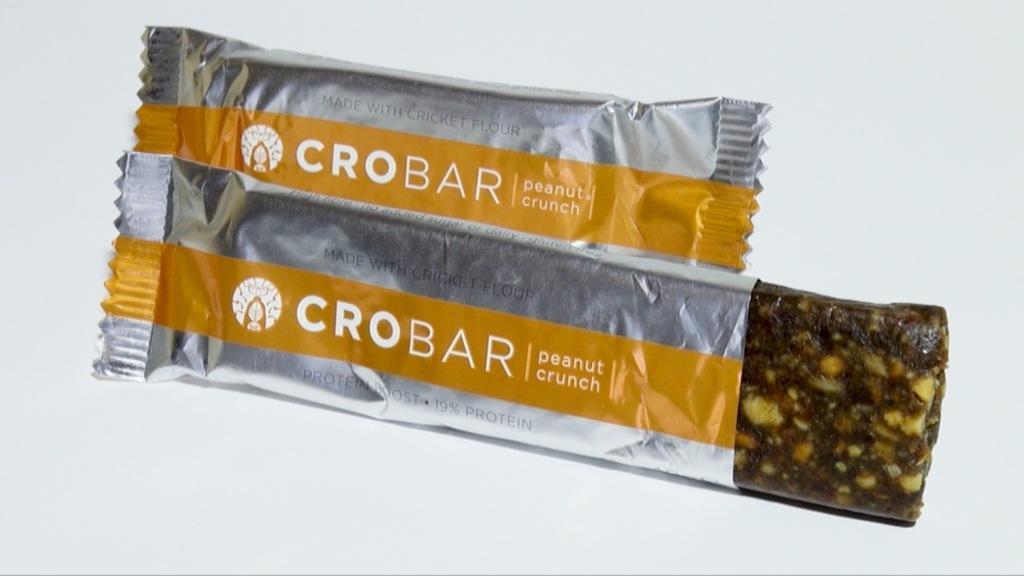Please provide a concise description of this image. In the center of the image we can see a choco bar is present. 